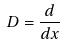Convert formula to latex. <formula><loc_0><loc_0><loc_500><loc_500>D = \frac { d } { d x }</formula> 